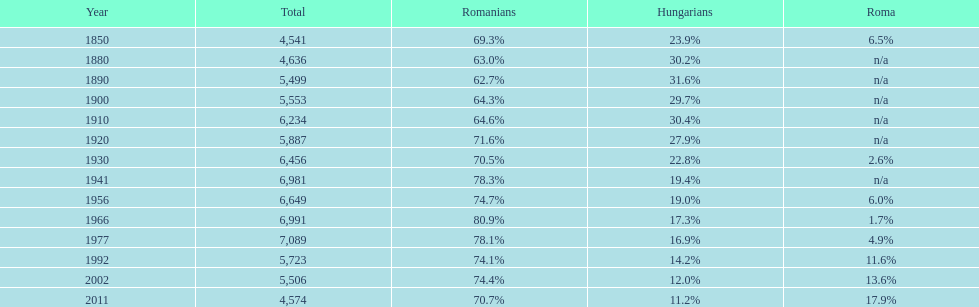In which year were there 6,981 and 1 1941. 